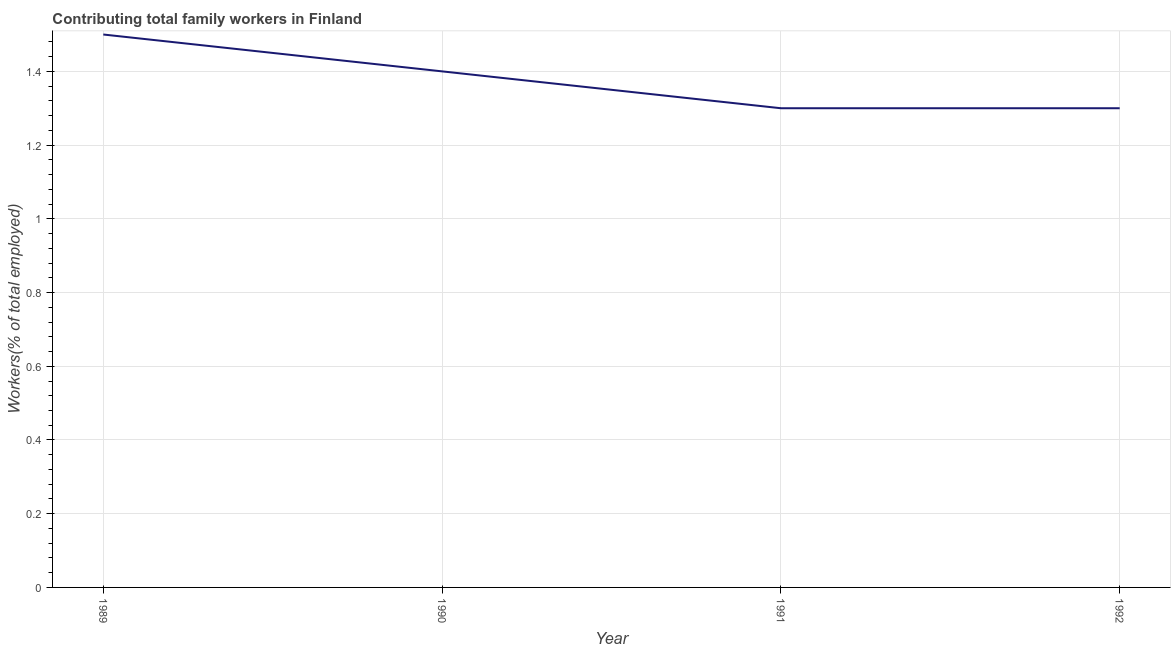Across all years, what is the minimum contributing family workers?
Ensure brevity in your answer.  1.3. In which year was the contributing family workers maximum?
Your response must be concise. 1989. What is the sum of the contributing family workers?
Your answer should be very brief. 5.5. What is the difference between the contributing family workers in 1990 and 1992?
Provide a short and direct response. 0.1. What is the average contributing family workers per year?
Keep it short and to the point. 1.37. What is the median contributing family workers?
Your response must be concise. 1.35. In how many years, is the contributing family workers greater than 0.7200000000000001 %?
Offer a terse response. 4. What is the ratio of the contributing family workers in 1990 to that in 1992?
Make the answer very short. 1.08. Is the contributing family workers in 1989 less than that in 1990?
Provide a short and direct response. No. What is the difference between the highest and the second highest contributing family workers?
Give a very brief answer. 0.1. Is the sum of the contributing family workers in 1990 and 1992 greater than the maximum contributing family workers across all years?
Your answer should be compact. Yes. What is the difference between the highest and the lowest contributing family workers?
Provide a succinct answer. 0.2. How many lines are there?
Your answer should be compact. 1. How many years are there in the graph?
Ensure brevity in your answer.  4. What is the difference between two consecutive major ticks on the Y-axis?
Your answer should be very brief. 0.2. Are the values on the major ticks of Y-axis written in scientific E-notation?
Keep it short and to the point. No. Does the graph contain grids?
Keep it short and to the point. Yes. What is the title of the graph?
Ensure brevity in your answer.  Contributing total family workers in Finland. What is the label or title of the X-axis?
Keep it short and to the point. Year. What is the label or title of the Y-axis?
Give a very brief answer. Workers(% of total employed). What is the Workers(% of total employed) of 1989?
Provide a succinct answer. 1.5. What is the Workers(% of total employed) in 1990?
Provide a succinct answer. 1.4. What is the Workers(% of total employed) of 1991?
Your answer should be very brief. 1.3. What is the Workers(% of total employed) in 1992?
Provide a succinct answer. 1.3. What is the difference between the Workers(% of total employed) in 1989 and 1990?
Offer a very short reply. 0.1. What is the difference between the Workers(% of total employed) in 1989 and 1992?
Give a very brief answer. 0.2. What is the difference between the Workers(% of total employed) in 1991 and 1992?
Offer a very short reply. 0. What is the ratio of the Workers(% of total employed) in 1989 to that in 1990?
Provide a short and direct response. 1.07. What is the ratio of the Workers(% of total employed) in 1989 to that in 1991?
Make the answer very short. 1.15. What is the ratio of the Workers(% of total employed) in 1989 to that in 1992?
Your answer should be compact. 1.15. What is the ratio of the Workers(% of total employed) in 1990 to that in 1991?
Give a very brief answer. 1.08. What is the ratio of the Workers(% of total employed) in 1990 to that in 1992?
Provide a short and direct response. 1.08. What is the ratio of the Workers(% of total employed) in 1991 to that in 1992?
Ensure brevity in your answer.  1. 